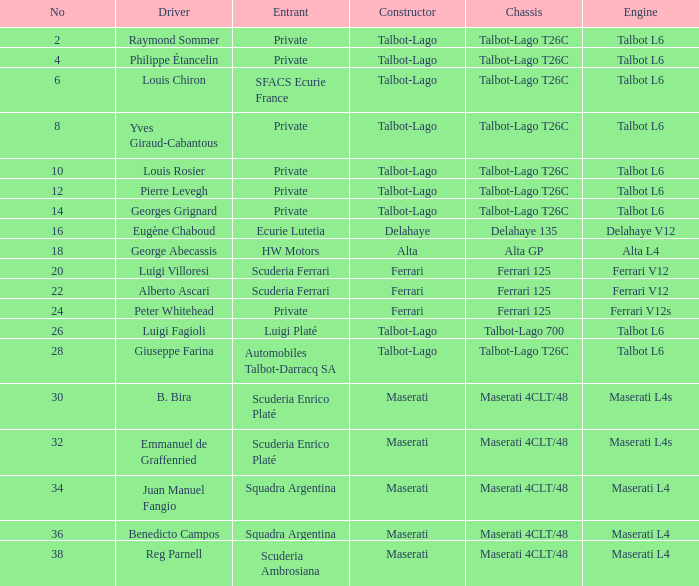Identify the frame for sfacs ecurie france Talbot-Lago T26C. 